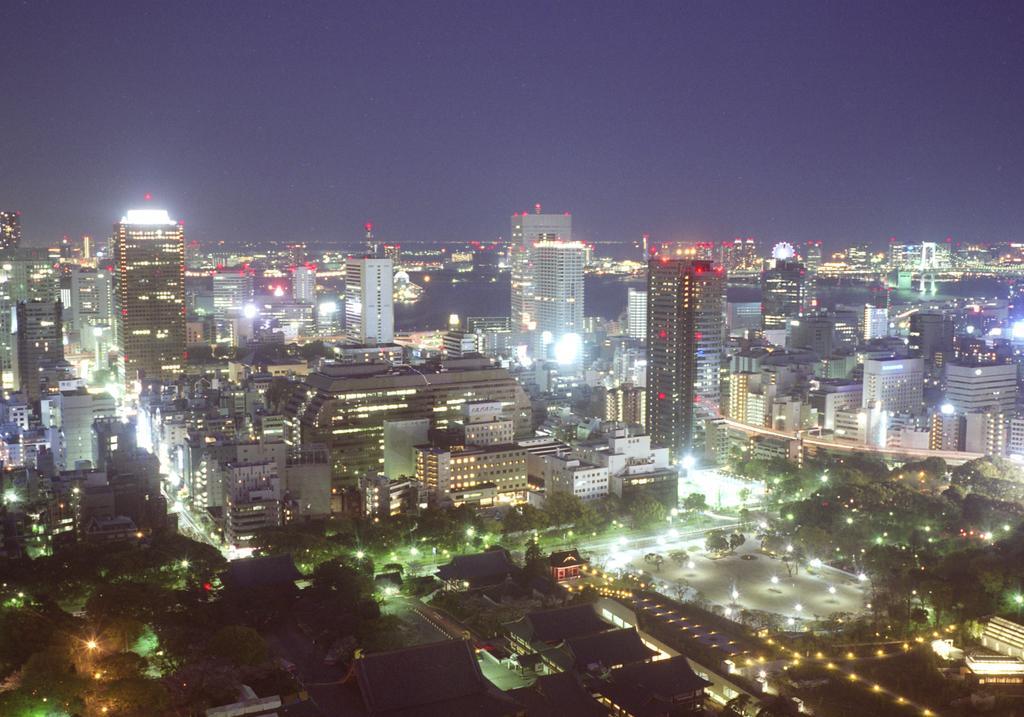Can you describe this image briefly? In the foreground of the image we can see houses and lights. In the middle of the image we can see tall buildings. On the top of the image we can see the sky. 